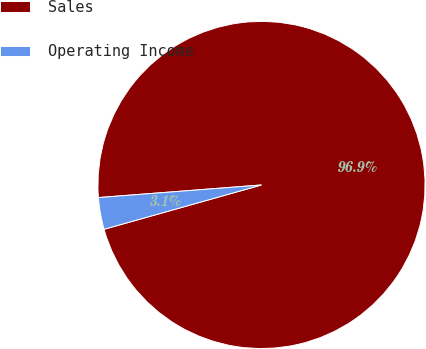Convert chart. <chart><loc_0><loc_0><loc_500><loc_500><pie_chart><fcel>Sales<fcel>Operating Income<nl><fcel>96.86%<fcel>3.14%<nl></chart> 